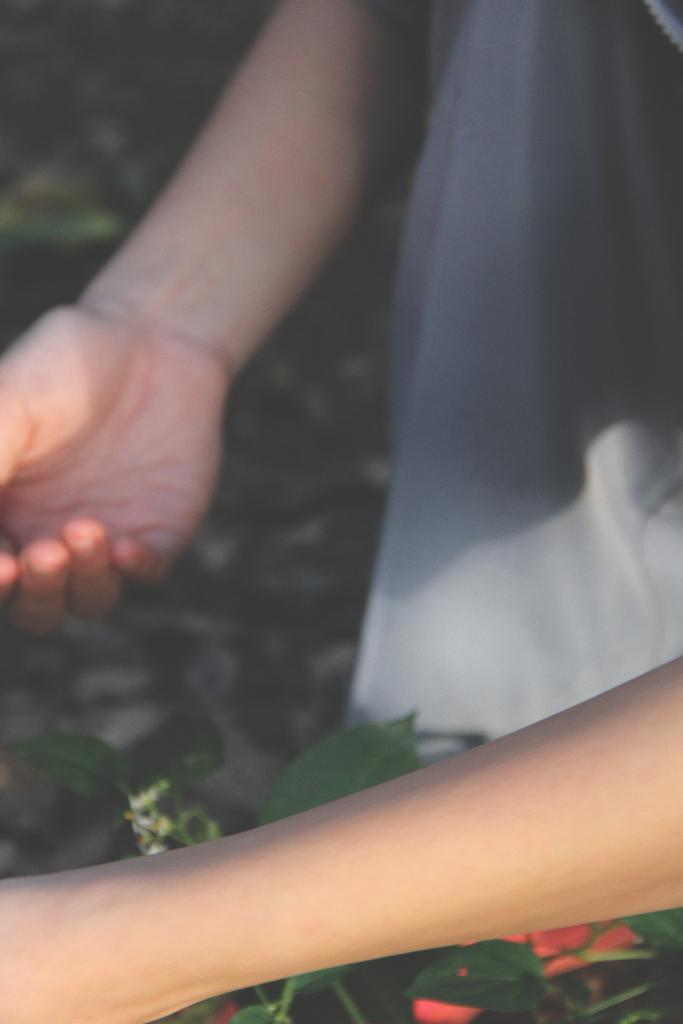What is the main subject of the image? There is a human in the image. What is the human doing in the image? The human is holding a plant. What type of clothing is the human wearing? The human is wearing a t-shirt. What type of brush can be seen in the image? There is no brush present in the image. Can you describe the nest in the image? There is no nest present in the image. 